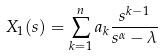<formula> <loc_0><loc_0><loc_500><loc_500>X _ { 1 } ( s ) = \sum _ { k = 1 } ^ { n } a _ { k } \frac { s ^ { k - 1 } } { s ^ { \alpha } - \lambda } \</formula> 